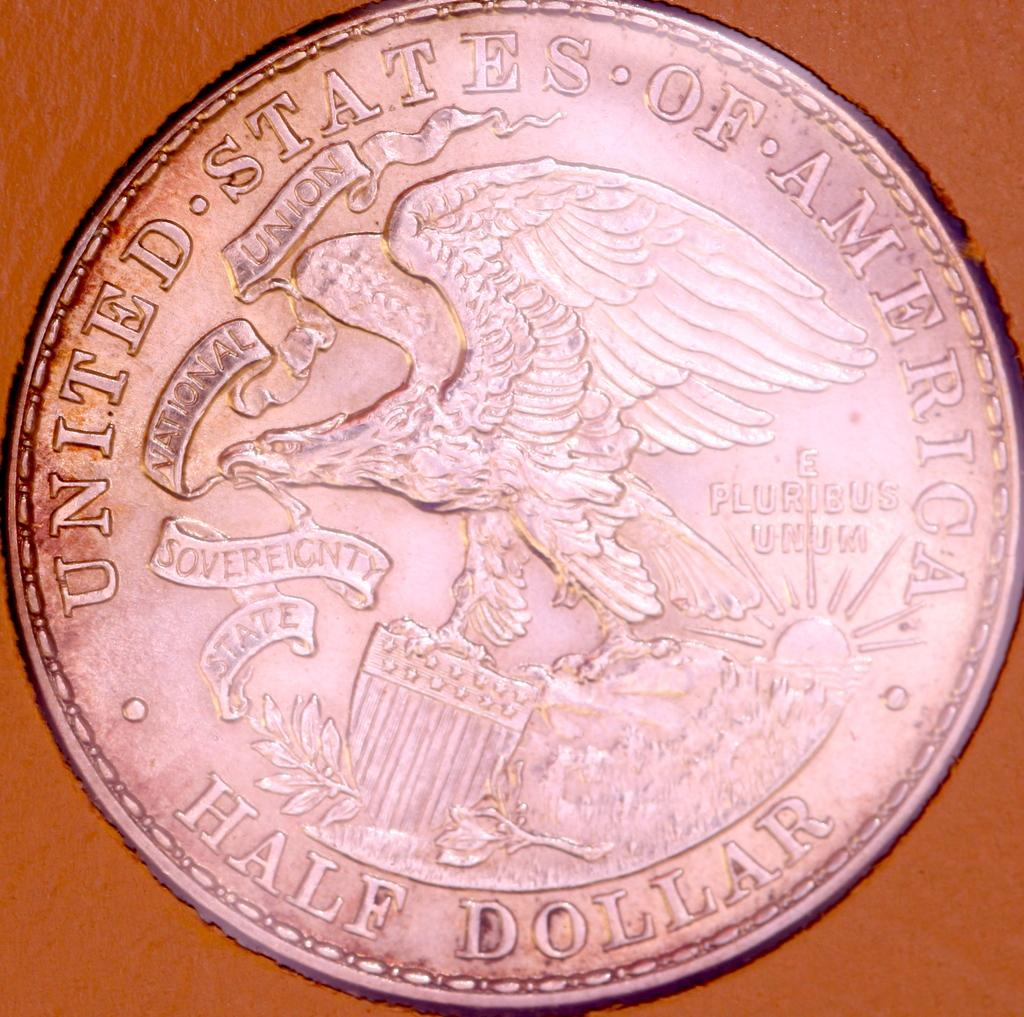<image>
Write a terse but informative summary of the picture. A U.S. half dollar coin includes the image of an eagle. 